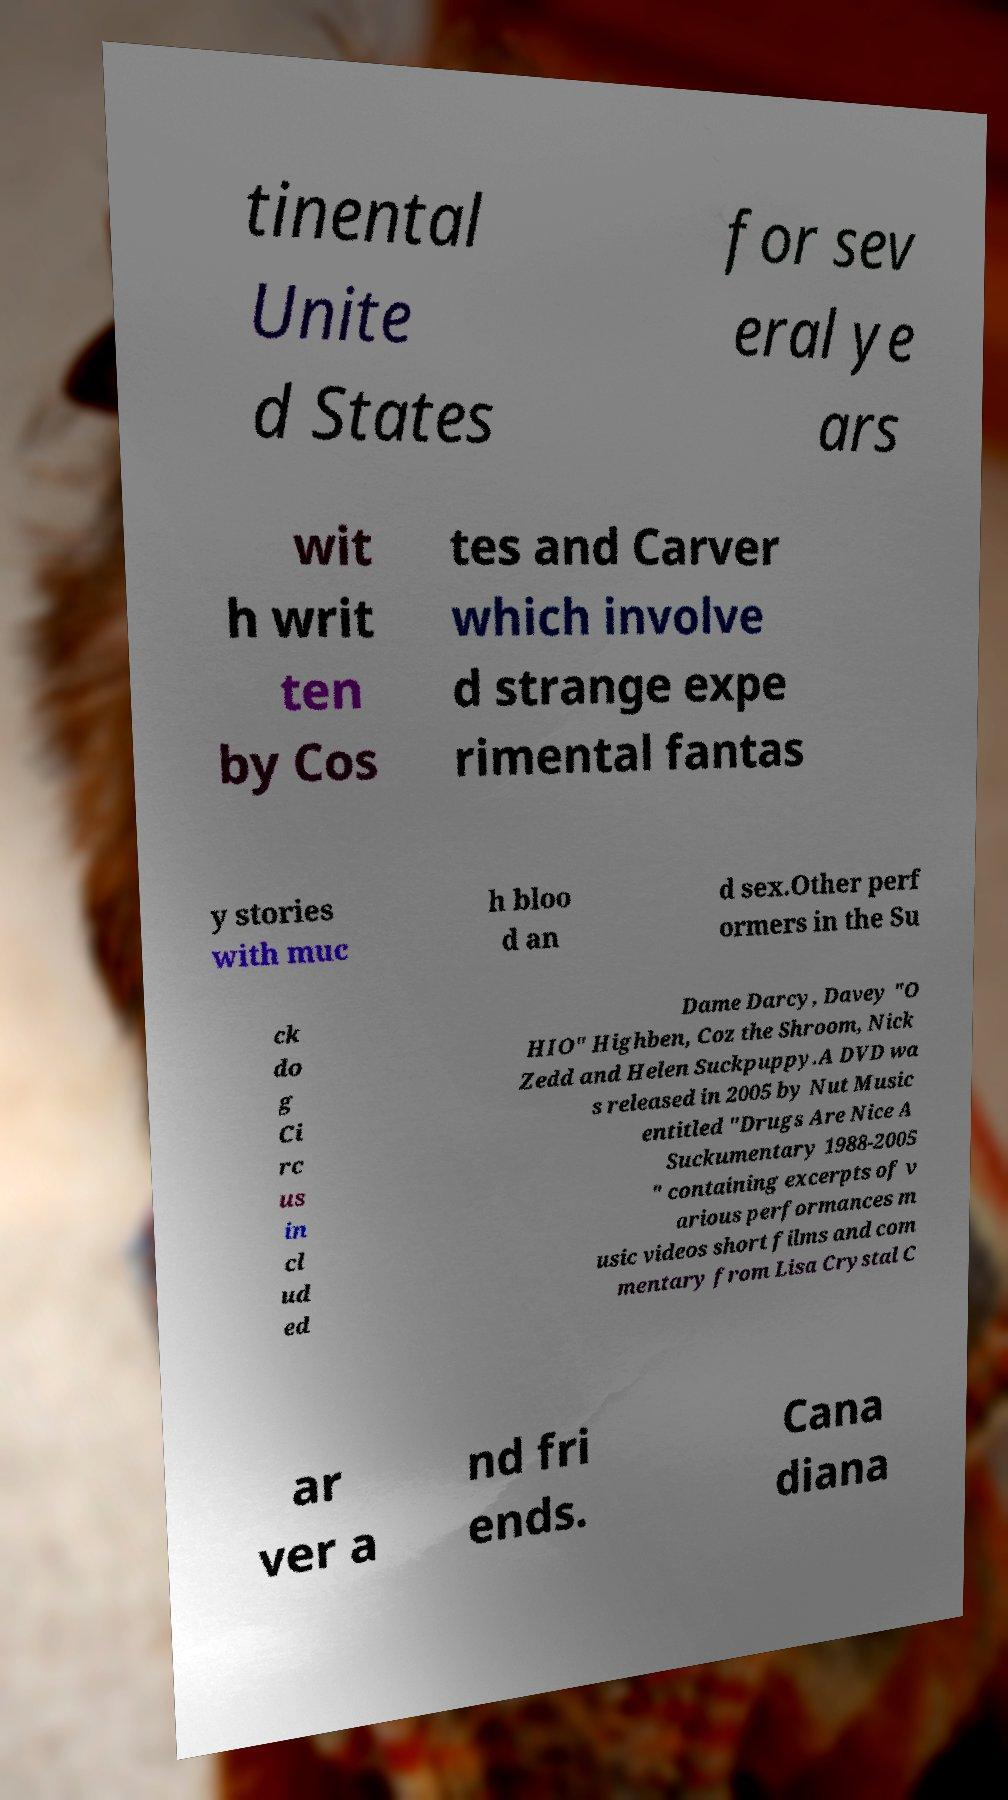There's text embedded in this image that I need extracted. Can you transcribe it verbatim? tinental Unite d States for sev eral ye ars wit h writ ten by Cos tes and Carver which involve d strange expe rimental fantas y stories with muc h bloo d an d sex.Other perf ormers in the Su ck do g Ci rc us in cl ud ed Dame Darcy, Davey "O HIO" Highben, Coz the Shroom, Nick Zedd and Helen Suckpuppy.A DVD wa s released in 2005 by Nut Music entitled "Drugs Are Nice A Suckumentary 1988-2005 " containing excerpts of v arious performances m usic videos short films and com mentary from Lisa Crystal C ar ver a nd fri ends. Cana diana 